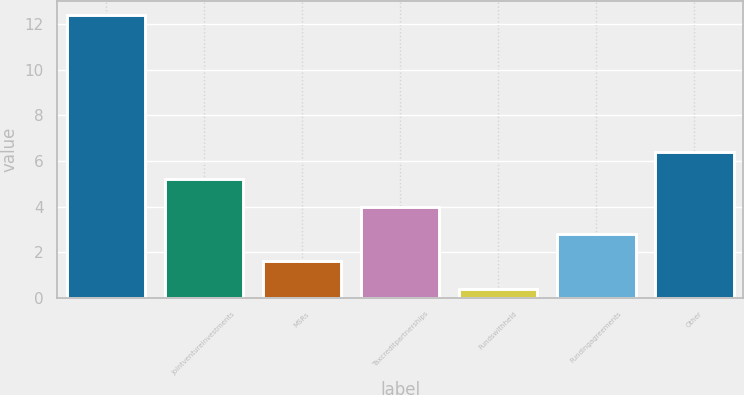Convert chart to OTSL. <chart><loc_0><loc_0><loc_500><loc_500><bar_chart><ecel><fcel>Jointventureinvestments<fcel>MSRs<fcel>Taxcreditpartnerships<fcel>Fundswithheld<fcel>Fundingagreements<fcel>Other<nl><fcel>12.4<fcel>5.2<fcel>1.6<fcel>4<fcel>0.4<fcel>2.8<fcel>6.4<nl></chart> 